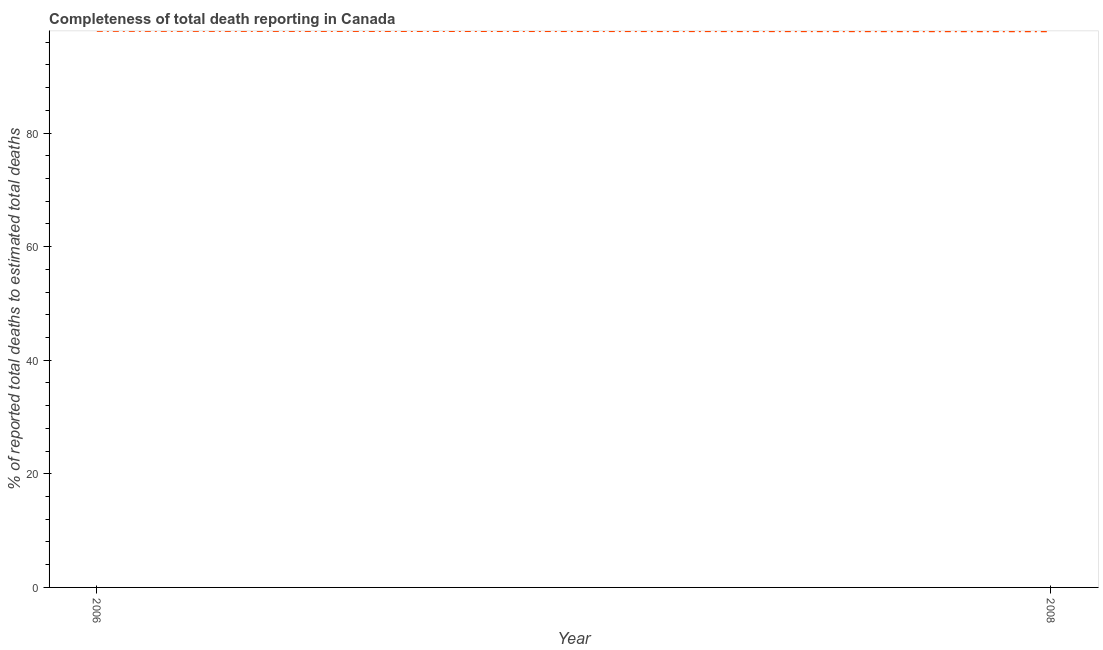What is the completeness of total death reports in 2008?
Your answer should be compact. 97.92. Across all years, what is the maximum completeness of total death reports?
Offer a terse response. 97.99. Across all years, what is the minimum completeness of total death reports?
Give a very brief answer. 97.92. In which year was the completeness of total death reports minimum?
Your response must be concise. 2008. What is the sum of the completeness of total death reports?
Give a very brief answer. 195.91. What is the difference between the completeness of total death reports in 2006 and 2008?
Your response must be concise. 0.07. What is the average completeness of total death reports per year?
Give a very brief answer. 97.95. What is the median completeness of total death reports?
Give a very brief answer. 97.95. Do a majority of the years between 2006 and 2008 (inclusive) have completeness of total death reports greater than 20 %?
Your answer should be compact. Yes. What is the ratio of the completeness of total death reports in 2006 to that in 2008?
Provide a short and direct response. 1. How many lines are there?
Your answer should be very brief. 1. Does the graph contain grids?
Provide a short and direct response. No. What is the title of the graph?
Your response must be concise. Completeness of total death reporting in Canada. What is the label or title of the X-axis?
Provide a succinct answer. Year. What is the label or title of the Y-axis?
Ensure brevity in your answer.  % of reported total deaths to estimated total deaths. What is the % of reported total deaths to estimated total deaths of 2006?
Keep it short and to the point. 97.99. What is the % of reported total deaths to estimated total deaths in 2008?
Your response must be concise. 97.92. What is the difference between the % of reported total deaths to estimated total deaths in 2006 and 2008?
Ensure brevity in your answer.  0.07. 